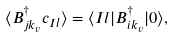<formula> <loc_0><loc_0><loc_500><loc_500>\langle B ^ { \dag } _ { j k _ { v } } c _ { I l } \rangle = \langle I l | B ^ { \dag } _ { i k _ { v } } | 0 \rangle ,</formula> 